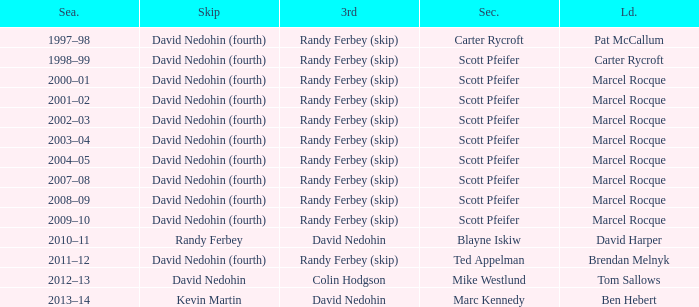Which Second has a Third of david nedohin, and a Lead of ben hebert? Marc Kennedy. Help me parse the entirety of this table. {'header': ['Sea.', 'Skip', '3rd', 'Sec.', 'Ld.'], 'rows': [['1997–98', 'David Nedohin (fourth)', 'Randy Ferbey (skip)', 'Carter Rycroft', 'Pat McCallum'], ['1998–99', 'David Nedohin (fourth)', 'Randy Ferbey (skip)', 'Scott Pfeifer', 'Carter Rycroft'], ['2000–01', 'David Nedohin (fourth)', 'Randy Ferbey (skip)', 'Scott Pfeifer', 'Marcel Rocque'], ['2001–02', 'David Nedohin (fourth)', 'Randy Ferbey (skip)', 'Scott Pfeifer', 'Marcel Rocque'], ['2002–03', 'David Nedohin (fourth)', 'Randy Ferbey (skip)', 'Scott Pfeifer', 'Marcel Rocque'], ['2003–04', 'David Nedohin (fourth)', 'Randy Ferbey (skip)', 'Scott Pfeifer', 'Marcel Rocque'], ['2004–05', 'David Nedohin (fourth)', 'Randy Ferbey (skip)', 'Scott Pfeifer', 'Marcel Rocque'], ['2007–08', 'David Nedohin (fourth)', 'Randy Ferbey (skip)', 'Scott Pfeifer', 'Marcel Rocque'], ['2008–09', 'David Nedohin (fourth)', 'Randy Ferbey (skip)', 'Scott Pfeifer', 'Marcel Rocque'], ['2009–10', 'David Nedohin (fourth)', 'Randy Ferbey (skip)', 'Scott Pfeifer', 'Marcel Rocque'], ['2010–11', 'Randy Ferbey', 'David Nedohin', 'Blayne Iskiw', 'David Harper'], ['2011–12', 'David Nedohin (fourth)', 'Randy Ferbey (skip)', 'Ted Appelman', 'Brendan Melnyk'], ['2012–13', 'David Nedohin', 'Colin Hodgson', 'Mike Westlund', 'Tom Sallows'], ['2013–14', 'Kevin Martin', 'David Nedohin', 'Marc Kennedy', 'Ben Hebert']]} 